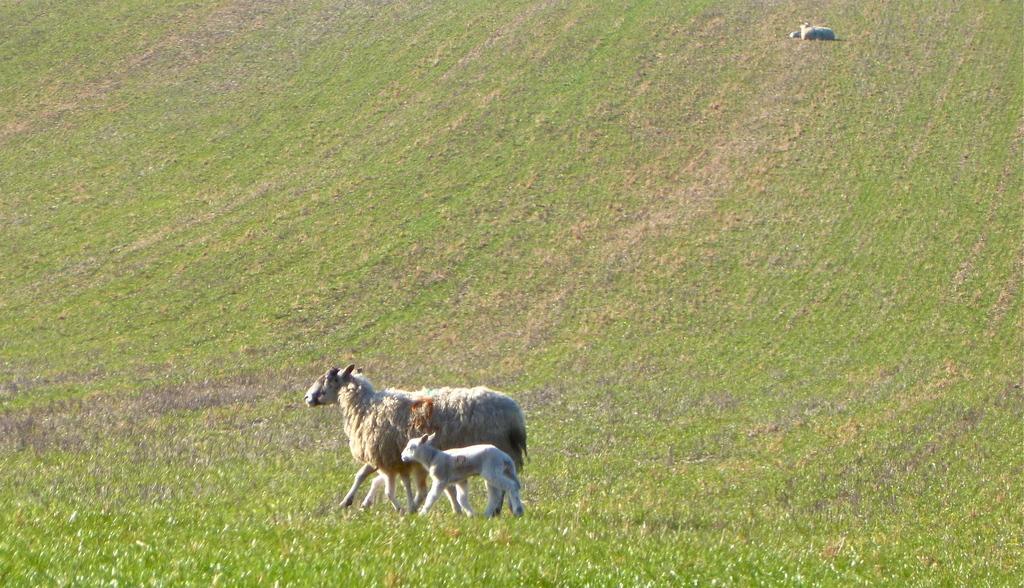In one or two sentences, can you explain what this image depicts? In the image on the ground there is grass. And also there is a sheep and lamb standing on the ground. At the top of the image on the ground there is an animal sitting. 